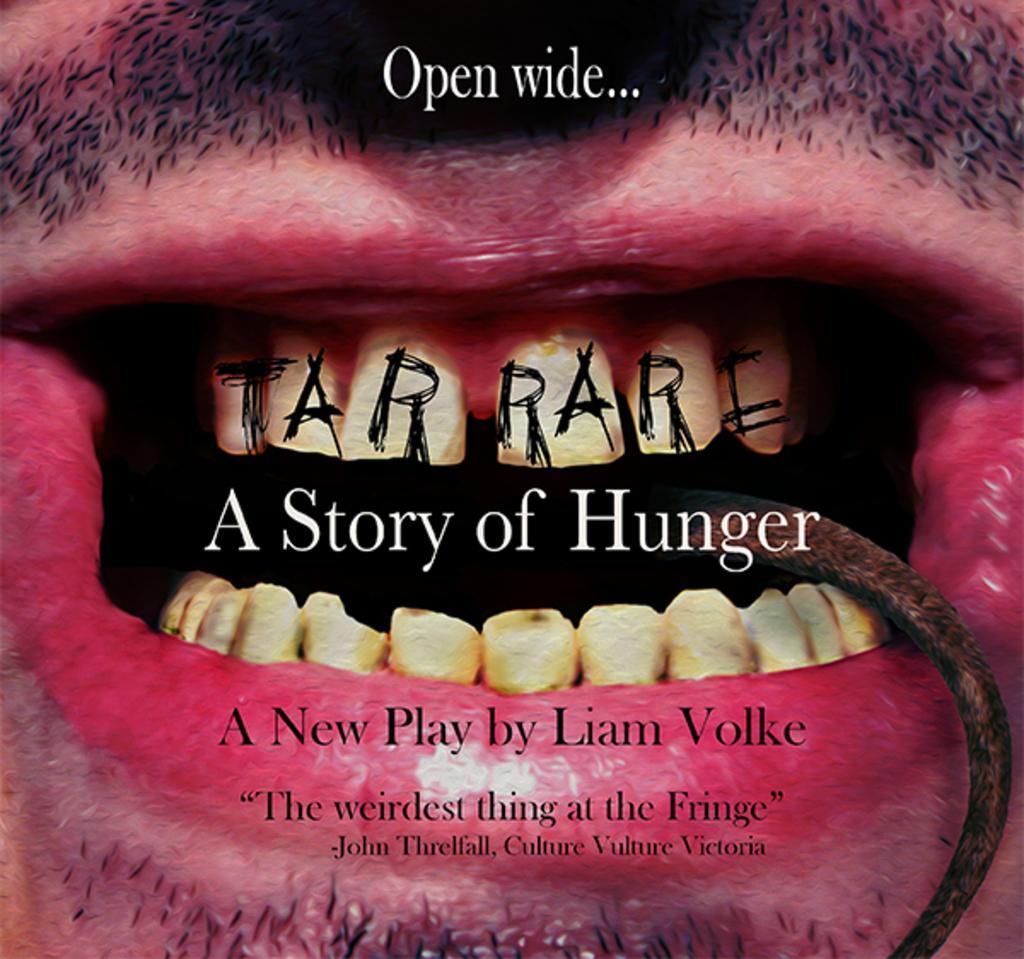Can you describe this image briefly? In this image I can see the person's mouth, teeth and something is written on it. 